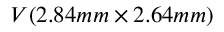Convert formula to latex. <formula><loc_0><loc_0><loc_500><loc_500>V ( 2 . 8 4 m m \times 2 . 6 4 m m )</formula> 